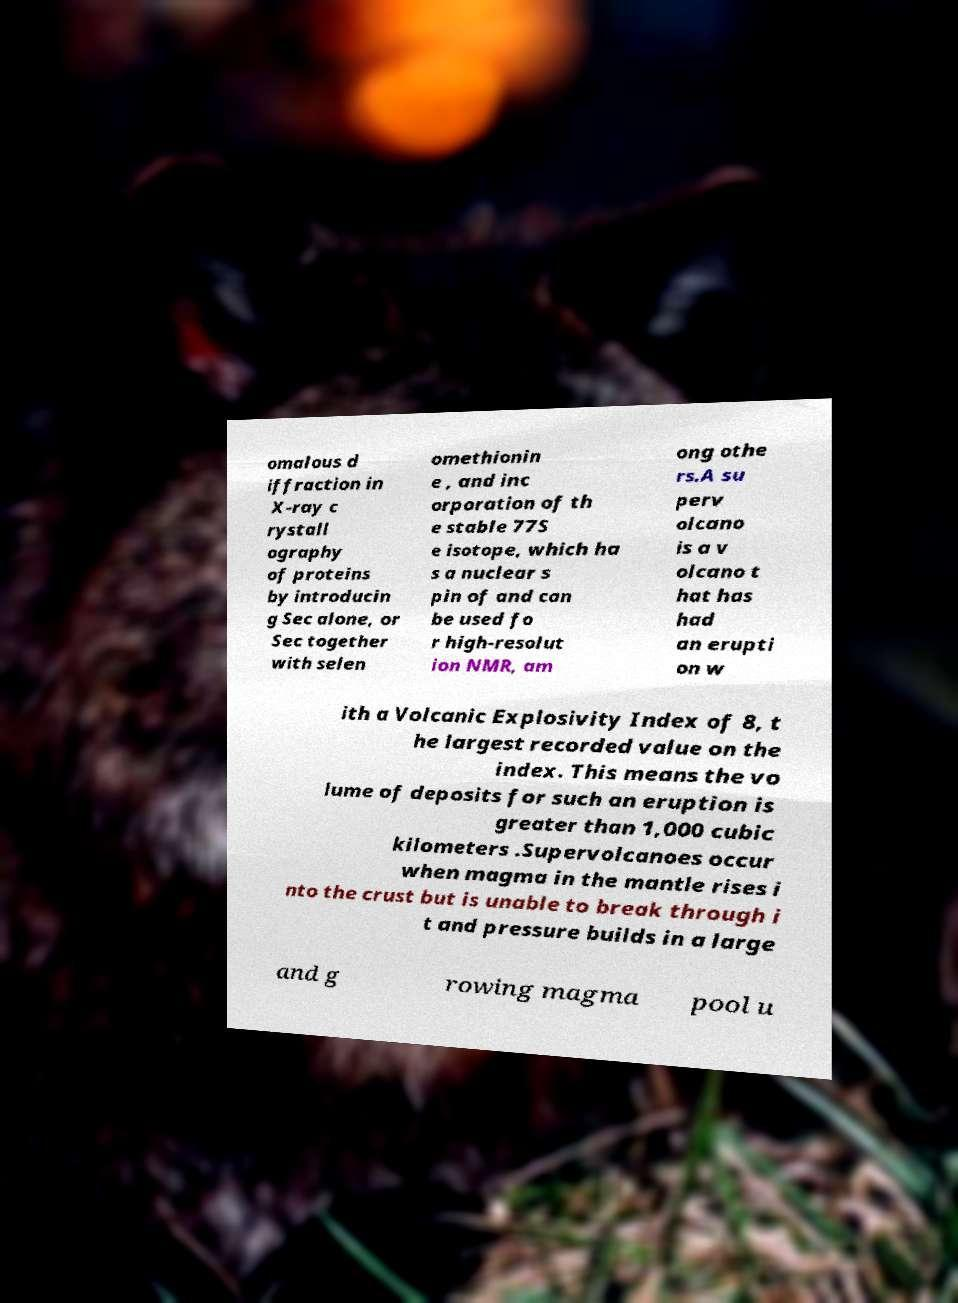There's text embedded in this image that I need extracted. Can you transcribe it verbatim? omalous d iffraction in X-ray c rystall ography of proteins by introducin g Sec alone, or Sec together with selen omethionin e , and inc orporation of th e stable 77S e isotope, which ha s a nuclear s pin of and can be used fo r high-resolut ion NMR, am ong othe rs.A su perv olcano is a v olcano t hat has had an erupti on w ith a Volcanic Explosivity Index of 8, t he largest recorded value on the index. This means the vo lume of deposits for such an eruption is greater than 1,000 cubic kilometers .Supervolcanoes occur when magma in the mantle rises i nto the crust but is unable to break through i t and pressure builds in a large and g rowing magma pool u 